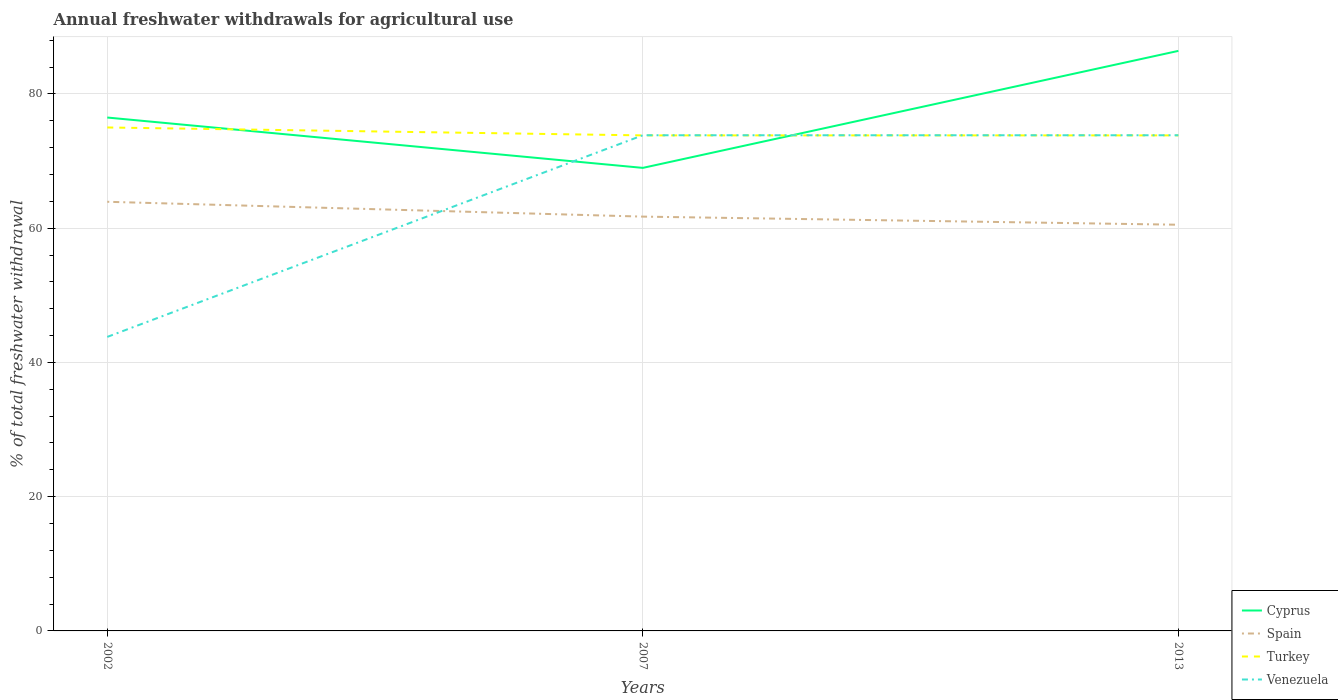Across all years, what is the maximum total annual withdrawals from freshwater in Cyprus?
Offer a very short reply. 68.98. What is the total total annual withdrawals from freshwater in Spain in the graph?
Your response must be concise. 2.21. What is the difference between the highest and the second highest total annual withdrawals from freshwater in Cyprus?
Ensure brevity in your answer.  17.43. What is the difference between the highest and the lowest total annual withdrawals from freshwater in Cyprus?
Offer a terse response. 1. Is the total annual withdrawals from freshwater in Turkey strictly greater than the total annual withdrawals from freshwater in Cyprus over the years?
Your answer should be compact. No. How many years are there in the graph?
Your response must be concise. 3. What is the difference between two consecutive major ticks on the Y-axis?
Ensure brevity in your answer.  20. Are the values on the major ticks of Y-axis written in scientific E-notation?
Give a very brief answer. No. Does the graph contain grids?
Give a very brief answer. Yes. How many legend labels are there?
Your answer should be very brief. 4. What is the title of the graph?
Offer a very short reply. Annual freshwater withdrawals for agricultural use. What is the label or title of the Y-axis?
Make the answer very short. % of total freshwater withdrawal. What is the % of total freshwater withdrawal in Cyprus in 2002?
Provide a short and direct response. 76.48. What is the % of total freshwater withdrawal in Spain in 2002?
Provide a short and direct response. 63.93. What is the % of total freshwater withdrawal in Turkey in 2002?
Offer a very short reply. 75. What is the % of total freshwater withdrawal of Venezuela in 2002?
Your response must be concise. 43.8. What is the % of total freshwater withdrawal in Cyprus in 2007?
Your answer should be very brief. 68.98. What is the % of total freshwater withdrawal of Spain in 2007?
Give a very brief answer. 61.72. What is the % of total freshwater withdrawal in Turkey in 2007?
Keep it short and to the point. 73.82. What is the % of total freshwater withdrawal of Venezuela in 2007?
Offer a terse response. 73.84. What is the % of total freshwater withdrawal in Cyprus in 2013?
Your response must be concise. 86.41. What is the % of total freshwater withdrawal of Spain in 2013?
Your answer should be very brief. 60.51. What is the % of total freshwater withdrawal in Turkey in 2013?
Keep it short and to the point. 73.82. What is the % of total freshwater withdrawal of Venezuela in 2013?
Your answer should be compact. 73.84. Across all years, what is the maximum % of total freshwater withdrawal of Cyprus?
Offer a very short reply. 86.41. Across all years, what is the maximum % of total freshwater withdrawal in Spain?
Your answer should be compact. 63.93. Across all years, what is the maximum % of total freshwater withdrawal in Turkey?
Offer a terse response. 75. Across all years, what is the maximum % of total freshwater withdrawal of Venezuela?
Offer a very short reply. 73.84. Across all years, what is the minimum % of total freshwater withdrawal in Cyprus?
Offer a very short reply. 68.98. Across all years, what is the minimum % of total freshwater withdrawal in Spain?
Your answer should be very brief. 60.51. Across all years, what is the minimum % of total freshwater withdrawal of Turkey?
Give a very brief answer. 73.82. Across all years, what is the minimum % of total freshwater withdrawal in Venezuela?
Keep it short and to the point. 43.8. What is the total % of total freshwater withdrawal in Cyprus in the graph?
Give a very brief answer. 231.87. What is the total % of total freshwater withdrawal of Spain in the graph?
Offer a very short reply. 186.16. What is the total % of total freshwater withdrawal in Turkey in the graph?
Provide a short and direct response. 222.64. What is the total % of total freshwater withdrawal of Venezuela in the graph?
Your answer should be compact. 191.48. What is the difference between the % of total freshwater withdrawal of Spain in 2002 and that in 2007?
Offer a very short reply. 2.21. What is the difference between the % of total freshwater withdrawal of Turkey in 2002 and that in 2007?
Your answer should be very brief. 1.18. What is the difference between the % of total freshwater withdrawal of Venezuela in 2002 and that in 2007?
Offer a very short reply. -30.04. What is the difference between the % of total freshwater withdrawal in Cyprus in 2002 and that in 2013?
Ensure brevity in your answer.  -9.93. What is the difference between the % of total freshwater withdrawal in Spain in 2002 and that in 2013?
Ensure brevity in your answer.  3.42. What is the difference between the % of total freshwater withdrawal of Turkey in 2002 and that in 2013?
Provide a succinct answer. 1.18. What is the difference between the % of total freshwater withdrawal of Venezuela in 2002 and that in 2013?
Your answer should be very brief. -30.04. What is the difference between the % of total freshwater withdrawal in Cyprus in 2007 and that in 2013?
Your response must be concise. -17.43. What is the difference between the % of total freshwater withdrawal of Spain in 2007 and that in 2013?
Provide a succinct answer. 1.21. What is the difference between the % of total freshwater withdrawal in Cyprus in 2002 and the % of total freshwater withdrawal in Spain in 2007?
Offer a very short reply. 14.76. What is the difference between the % of total freshwater withdrawal in Cyprus in 2002 and the % of total freshwater withdrawal in Turkey in 2007?
Ensure brevity in your answer.  2.66. What is the difference between the % of total freshwater withdrawal of Cyprus in 2002 and the % of total freshwater withdrawal of Venezuela in 2007?
Give a very brief answer. 2.64. What is the difference between the % of total freshwater withdrawal of Spain in 2002 and the % of total freshwater withdrawal of Turkey in 2007?
Keep it short and to the point. -9.89. What is the difference between the % of total freshwater withdrawal of Spain in 2002 and the % of total freshwater withdrawal of Venezuela in 2007?
Offer a very short reply. -9.91. What is the difference between the % of total freshwater withdrawal in Turkey in 2002 and the % of total freshwater withdrawal in Venezuela in 2007?
Provide a succinct answer. 1.16. What is the difference between the % of total freshwater withdrawal in Cyprus in 2002 and the % of total freshwater withdrawal in Spain in 2013?
Your response must be concise. 15.97. What is the difference between the % of total freshwater withdrawal in Cyprus in 2002 and the % of total freshwater withdrawal in Turkey in 2013?
Offer a very short reply. 2.66. What is the difference between the % of total freshwater withdrawal in Cyprus in 2002 and the % of total freshwater withdrawal in Venezuela in 2013?
Offer a terse response. 2.64. What is the difference between the % of total freshwater withdrawal in Spain in 2002 and the % of total freshwater withdrawal in Turkey in 2013?
Your answer should be very brief. -9.89. What is the difference between the % of total freshwater withdrawal of Spain in 2002 and the % of total freshwater withdrawal of Venezuela in 2013?
Your answer should be very brief. -9.91. What is the difference between the % of total freshwater withdrawal in Turkey in 2002 and the % of total freshwater withdrawal in Venezuela in 2013?
Provide a short and direct response. 1.16. What is the difference between the % of total freshwater withdrawal in Cyprus in 2007 and the % of total freshwater withdrawal in Spain in 2013?
Offer a terse response. 8.47. What is the difference between the % of total freshwater withdrawal of Cyprus in 2007 and the % of total freshwater withdrawal of Turkey in 2013?
Your answer should be very brief. -4.84. What is the difference between the % of total freshwater withdrawal of Cyprus in 2007 and the % of total freshwater withdrawal of Venezuela in 2013?
Provide a short and direct response. -4.86. What is the difference between the % of total freshwater withdrawal of Spain in 2007 and the % of total freshwater withdrawal of Turkey in 2013?
Offer a terse response. -12.1. What is the difference between the % of total freshwater withdrawal of Spain in 2007 and the % of total freshwater withdrawal of Venezuela in 2013?
Give a very brief answer. -12.12. What is the difference between the % of total freshwater withdrawal of Turkey in 2007 and the % of total freshwater withdrawal of Venezuela in 2013?
Ensure brevity in your answer.  -0.02. What is the average % of total freshwater withdrawal of Cyprus per year?
Your answer should be very brief. 77.29. What is the average % of total freshwater withdrawal in Spain per year?
Ensure brevity in your answer.  62.05. What is the average % of total freshwater withdrawal of Turkey per year?
Ensure brevity in your answer.  74.21. What is the average % of total freshwater withdrawal of Venezuela per year?
Offer a terse response. 63.83. In the year 2002, what is the difference between the % of total freshwater withdrawal in Cyprus and % of total freshwater withdrawal in Spain?
Make the answer very short. 12.55. In the year 2002, what is the difference between the % of total freshwater withdrawal of Cyprus and % of total freshwater withdrawal of Turkey?
Your answer should be compact. 1.48. In the year 2002, what is the difference between the % of total freshwater withdrawal of Cyprus and % of total freshwater withdrawal of Venezuela?
Provide a short and direct response. 32.68. In the year 2002, what is the difference between the % of total freshwater withdrawal in Spain and % of total freshwater withdrawal in Turkey?
Provide a short and direct response. -11.07. In the year 2002, what is the difference between the % of total freshwater withdrawal in Spain and % of total freshwater withdrawal in Venezuela?
Provide a succinct answer. 20.13. In the year 2002, what is the difference between the % of total freshwater withdrawal in Turkey and % of total freshwater withdrawal in Venezuela?
Provide a short and direct response. 31.2. In the year 2007, what is the difference between the % of total freshwater withdrawal in Cyprus and % of total freshwater withdrawal in Spain?
Your answer should be compact. 7.26. In the year 2007, what is the difference between the % of total freshwater withdrawal in Cyprus and % of total freshwater withdrawal in Turkey?
Give a very brief answer. -4.84. In the year 2007, what is the difference between the % of total freshwater withdrawal of Cyprus and % of total freshwater withdrawal of Venezuela?
Keep it short and to the point. -4.86. In the year 2007, what is the difference between the % of total freshwater withdrawal of Spain and % of total freshwater withdrawal of Venezuela?
Give a very brief answer. -12.12. In the year 2007, what is the difference between the % of total freshwater withdrawal in Turkey and % of total freshwater withdrawal in Venezuela?
Your response must be concise. -0.02. In the year 2013, what is the difference between the % of total freshwater withdrawal of Cyprus and % of total freshwater withdrawal of Spain?
Offer a terse response. 25.9. In the year 2013, what is the difference between the % of total freshwater withdrawal in Cyprus and % of total freshwater withdrawal in Turkey?
Give a very brief answer. 12.59. In the year 2013, what is the difference between the % of total freshwater withdrawal of Cyprus and % of total freshwater withdrawal of Venezuela?
Keep it short and to the point. 12.57. In the year 2013, what is the difference between the % of total freshwater withdrawal in Spain and % of total freshwater withdrawal in Turkey?
Your answer should be compact. -13.31. In the year 2013, what is the difference between the % of total freshwater withdrawal in Spain and % of total freshwater withdrawal in Venezuela?
Ensure brevity in your answer.  -13.33. In the year 2013, what is the difference between the % of total freshwater withdrawal in Turkey and % of total freshwater withdrawal in Venezuela?
Keep it short and to the point. -0.02. What is the ratio of the % of total freshwater withdrawal of Cyprus in 2002 to that in 2007?
Your answer should be compact. 1.11. What is the ratio of the % of total freshwater withdrawal of Spain in 2002 to that in 2007?
Offer a terse response. 1.04. What is the ratio of the % of total freshwater withdrawal in Venezuela in 2002 to that in 2007?
Make the answer very short. 0.59. What is the ratio of the % of total freshwater withdrawal in Cyprus in 2002 to that in 2013?
Offer a terse response. 0.89. What is the ratio of the % of total freshwater withdrawal of Spain in 2002 to that in 2013?
Ensure brevity in your answer.  1.06. What is the ratio of the % of total freshwater withdrawal in Venezuela in 2002 to that in 2013?
Offer a terse response. 0.59. What is the ratio of the % of total freshwater withdrawal in Cyprus in 2007 to that in 2013?
Offer a very short reply. 0.8. What is the ratio of the % of total freshwater withdrawal in Spain in 2007 to that in 2013?
Offer a very short reply. 1.02. What is the ratio of the % of total freshwater withdrawal in Venezuela in 2007 to that in 2013?
Keep it short and to the point. 1. What is the difference between the highest and the second highest % of total freshwater withdrawal of Cyprus?
Offer a terse response. 9.93. What is the difference between the highest and the second highest % of total freshwater withdrawal of Spain?
Offer a very short reply. 2.21. What is the difference between the highest and the second highest % of total freshwater withdrawal of Turkey?
Offer a terse response. 1.18. What is the difference between the highest and the lowest % of total freshwater withdrawal in Cyprus?
Your answer should be very brief. 17.43. What is the difference between the highest and the lowest % of total freshwater withdrawal in Spain?
Your response must be concise. 3.42. What is the difference between the highest and the lowest % of total freshwater withdrawal of Turkey?
Provide a short and direct response. 1.18. What is the difference between the highest and the lowest % of total freshwater withdrawal in Venezuela?
Provide a short and direct response. 30.04. 